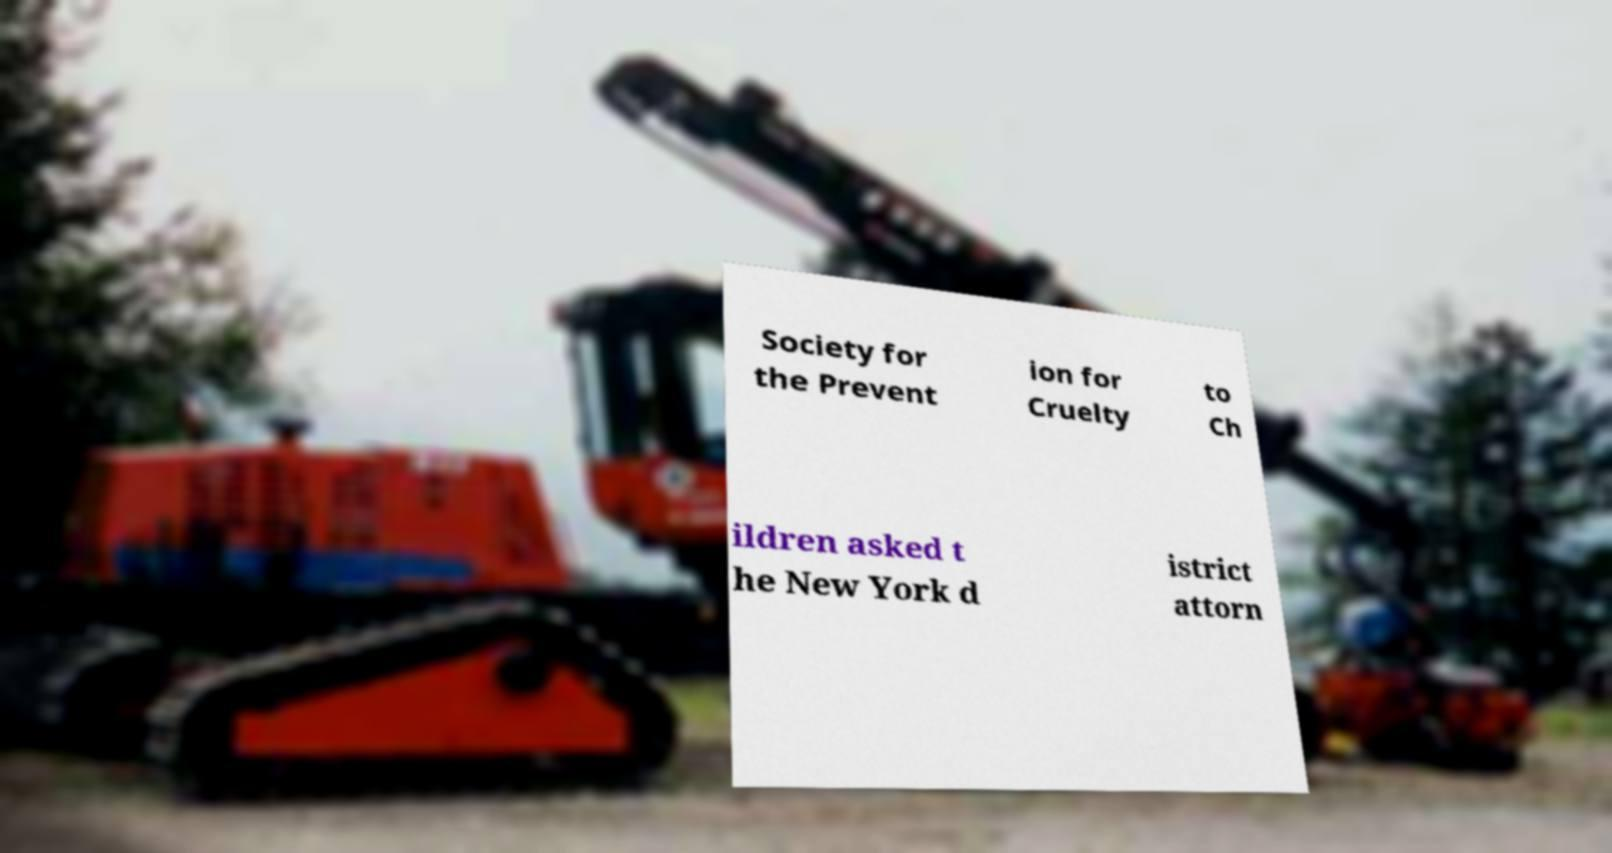I need the written content from this picture converted into text. Can you do that? Society for the Prevent ion for Cruelty to Ch ildren asked t he New York d istrict attorn 